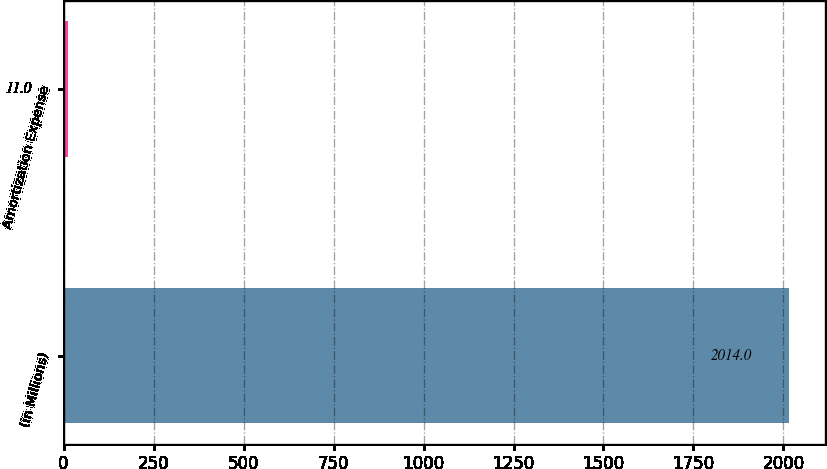<chart> <loc_0><loc_0><loc_500><loc_500><bar_chart><fcel>(in Millions)<fcel>Amortization Expense<nl><fcel>2014<fcel>11<nl></chart> 